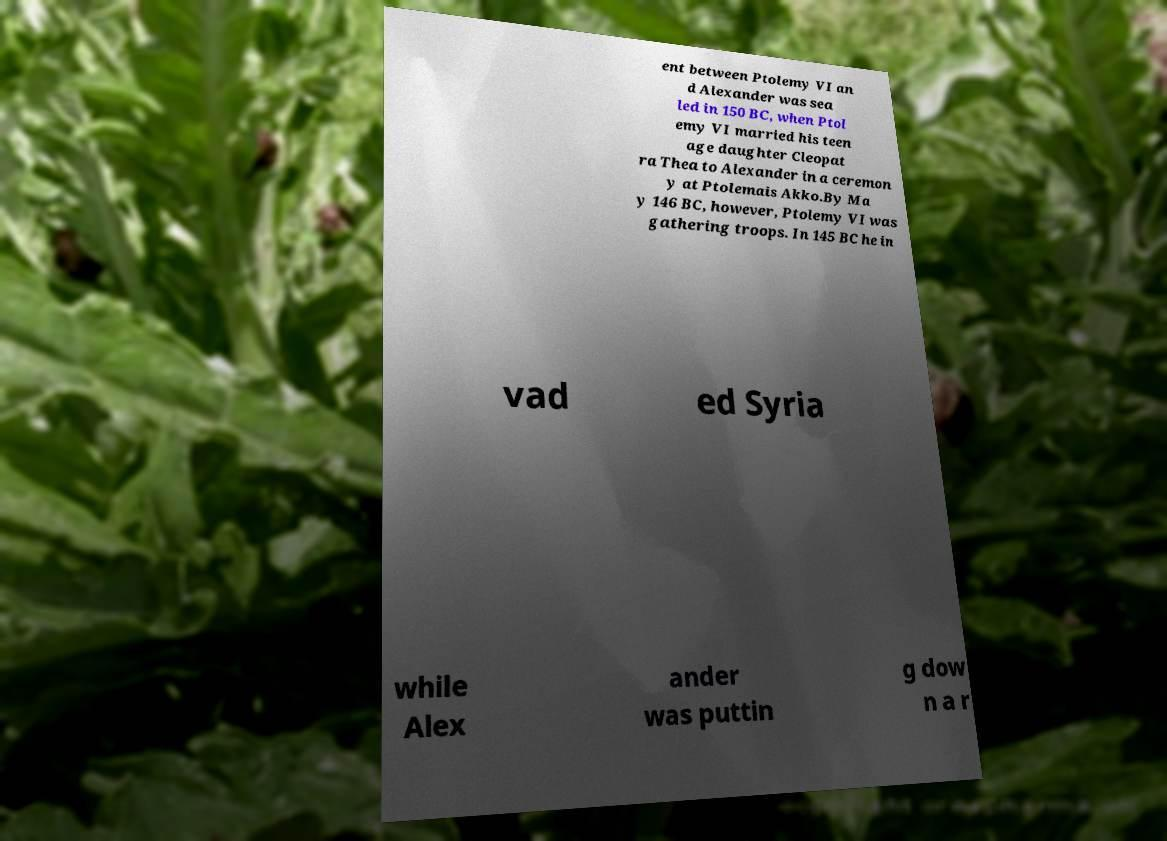Can you accurately transcribe the text from the provided image for me? ent between Ptolemy VI an d Alexander was sea led in 150 BC, when Ptol emy VI married his teen age daughter Cleopat ra Thea to Alexander in a ceremon y at Ptolemais Akko.By Ma y 146 BC, however, Ptolemy VI was gathering troops. In 145 BC he in vad ed Syria while Alex ander was puttin g dow n a r 